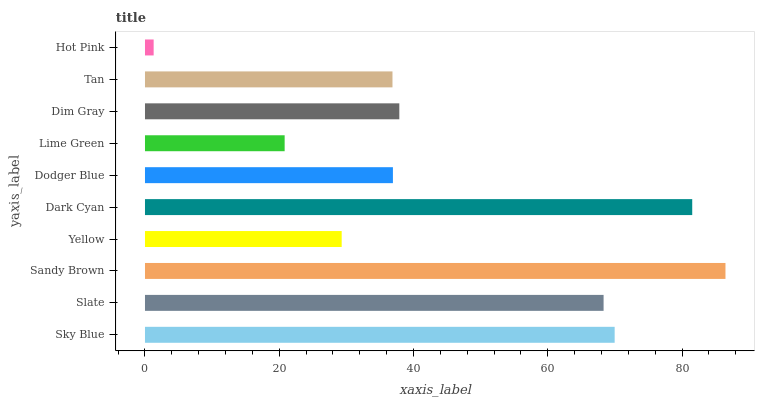Is Hot Pink the minimum?
Answer yes or no. Yes. Is Sandy Brown the maximum?
Answer yes or no. Yes. Is Slate the minimum?
Answer yes or no. No. Is Slate the maximum?
Answer yes or no. No. Is Sky Blue greater than Slate?
Answer yes or no. Yes. Is Slate less than Sky Blue?
Answer yes or no. Yes. Is Slate greater than Sky Blue?
Answer yes or no. No. Is Sky Blue less than Slate?
Answer yes or no. No. Is Dim Gray the high median?
Answer yes or no. Yes. Is Dodger Blue the low median?
Answer yes or no. Yes. Is Slate the high median?
Answer yes or no. No. Is Dim Gray the low median?
Answer yes or no. No. 